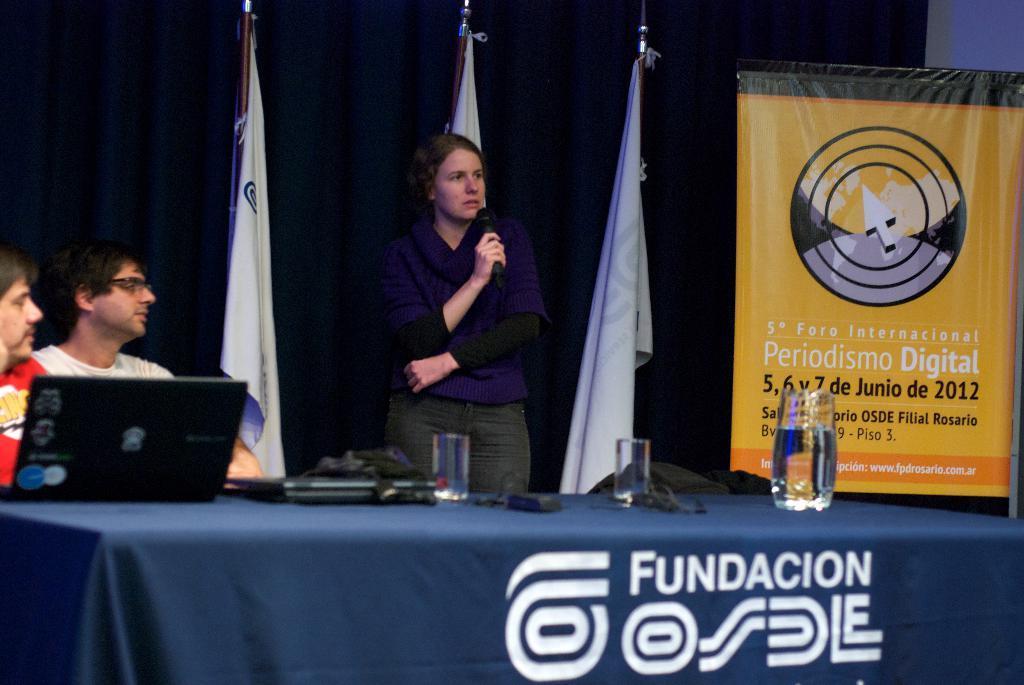In one or two sentences, can you explain what this image depicts? In this image these people sitting and there is a laptop on the table in the foreground. There is a flex board on the right corner. There is a person standing and she is holding a mike, there are objects on the table in the foreground. There are flags and there is a curtain in the background. 